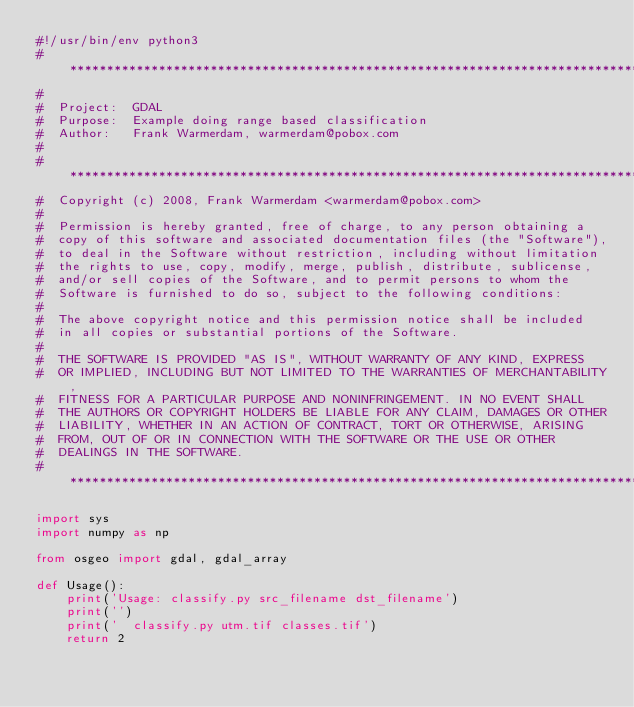<code> <loc_0><loc_0><loc_500><loc_500><_Python_>#!/usr/bin/env python3
# ******************************************************************************
#
#  Project:  GDAL
#  Purpose:  Example doing range based classification
#  Author:   Frank Warmerdam, warmerdam@pobox.com
#
# ******************************************************************************
#  Copyright (c) 2008, Frank Warmerdam <warmerdam@pobox.com>
#
#  Permission is hereby granted, free of charge, to any person obtaining a
#  copy of this software and associated documentation files (the "Software"),
#  to deal in the Software without restriction, including without limitation
#  the rights to use, copy, modify, merge, publish, distribute, sublicense,
#  and/or sell copies of the Software, and to permit persons to whom the
#  Software is furnished to do so, subject to the following conditions:
#
#  The above copyright notice and this permission notice shall be included
#  in all copies or substantial portions of the Software.
#
#  THE SOFTWARE IS PROVIDED "AS IS", WITHOUT WARRANTY OF ANY KIND, EXPRESS
#  OR IMPLIED, INCLUDING BUT NOT LIMITED TO THE WARRANTIES OF MERCHANTABILITY,
#  FITNESS FOR A PARTICULAR PURPOSE AND NONINFRINGEMENT. IN NO EVENT SHALL
#  THE AUTHORS OR COPYRIGHT HOLDERS BE LIABLE FOR ANY CLAIM, DAMAGES OR OTHER
#  LIABILITY, WHETHER IN AN ACTION OF CONTRACT, TORT OR OTHERWISE, ARISING
#  FROM, OUT OF OR IN CONNECTION WITH THE SOFTWARE OR THE USE OR OTHER
#  DEALINGS IN THE SOFTWARE.
# ******************************************************************************

import sys
import numpy as np

from osgeo import gdal, gdal_array

def Usage():
    print('Usage: classify.py src_filename dst_filename')
    print('')
    print('  classify.py utm.tif classes.tif')
    return 2
</code> 